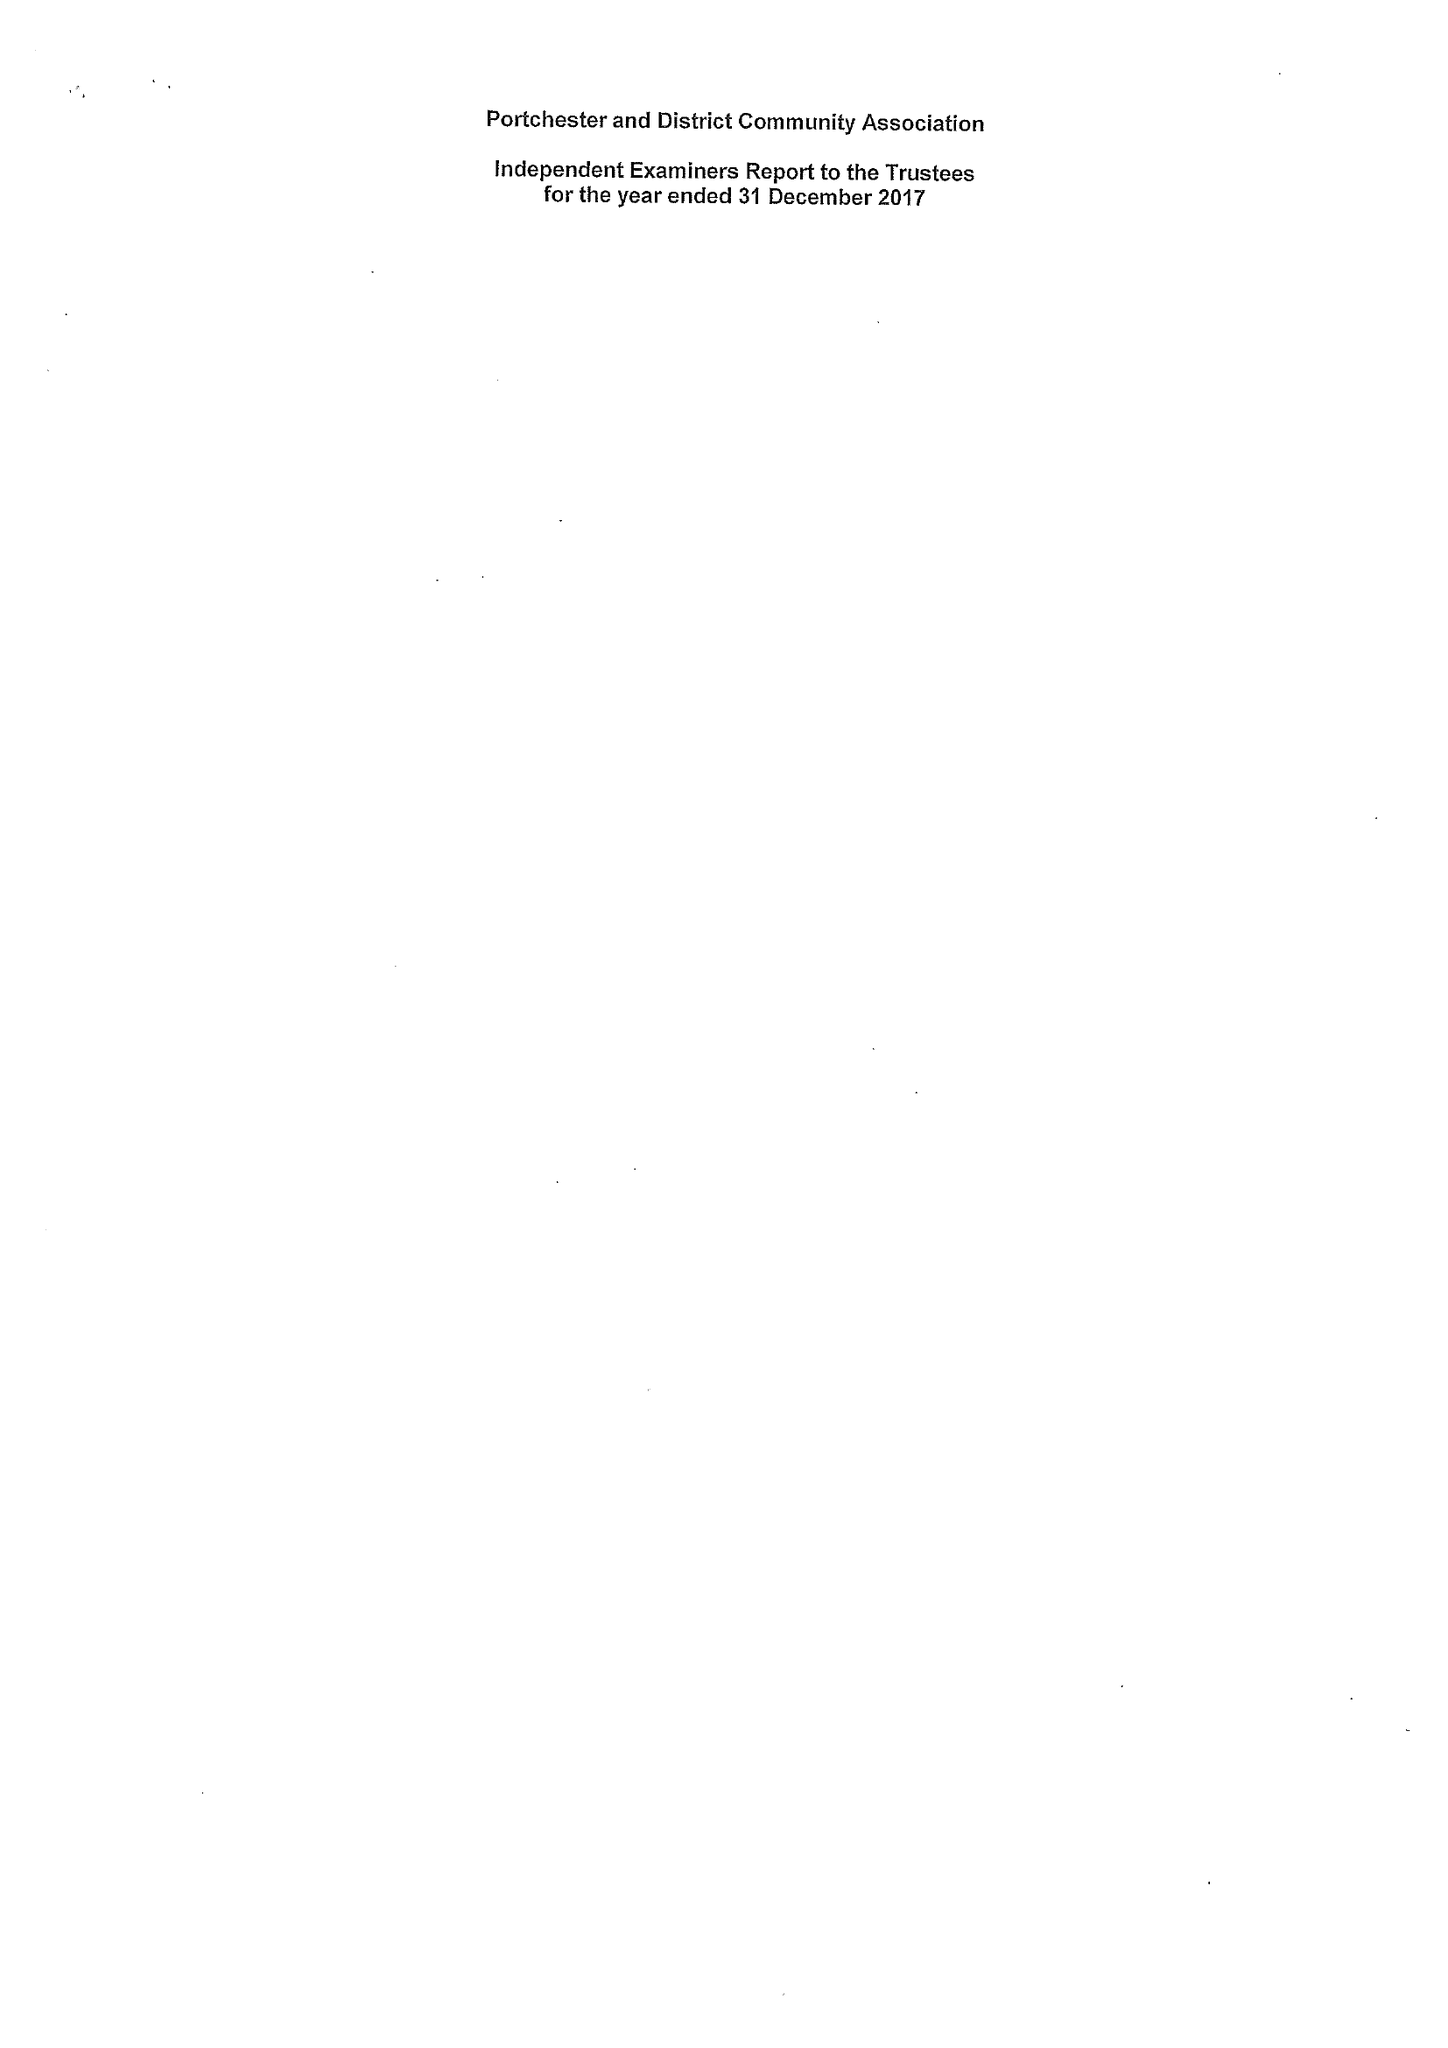What is the value for the address__postcode?
Answer the question using a single word or phrase. PO16 9UY 